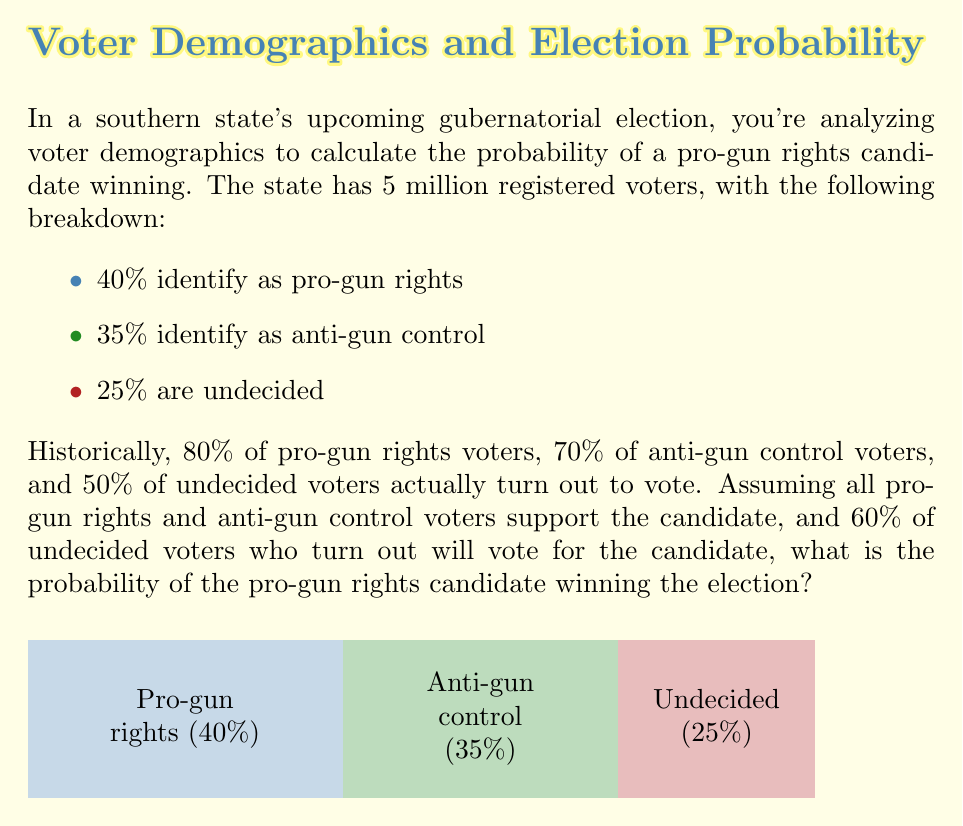Solve this math problem. Let's break this down step-by-step:

1) First, let's calculate the number of voters in each category:
   Pro-gun rights: $0.40 \times 5,000,000 = 2,000,000$
   Anti-gun control: $0.35 \times 5,000,000 = 1,750,000$
   Undecided: $0.25 \times 5,000,000 = 1,250,000$

2) Now, let's calculate the number of voters who will actually turn out:
   Pro-gun rights: $2,000,000 \times 0.80 = 1,600,000$
   Anti-gun control: $1,750,000 \times 0.70 = 1,225,000$
   Undecided: $1,250,000 \times 0.50 = 625,000$

3) Calculate the number of votes for the pro-gun rights candidate:
   Pro-gun rights: $1,600,000$ (all)
   Anti-gun control: $1,225,000$ (all)
   Undecided: $625,000 \times 0.60 = 375,000$

   Total votes for candidate: $1,600,000 + 1,225,000 + 375,000 = 3,200,000$

4) Calculate the total number of votes cast:
   $1,600,000 + 1,225,000 + 625,000 = 3,450,000$

5) The probability of winning is the number of votes for the candidate divided by the total votes cast:

   $$P(\text{win}) = \frac{3,200,000}{3,450,000} \approx 0.9275$$

Therefore, the probability of the pro-gun rights candidate winning is approximately 0.9275 or 92.75%.
Answer: 0.9275 